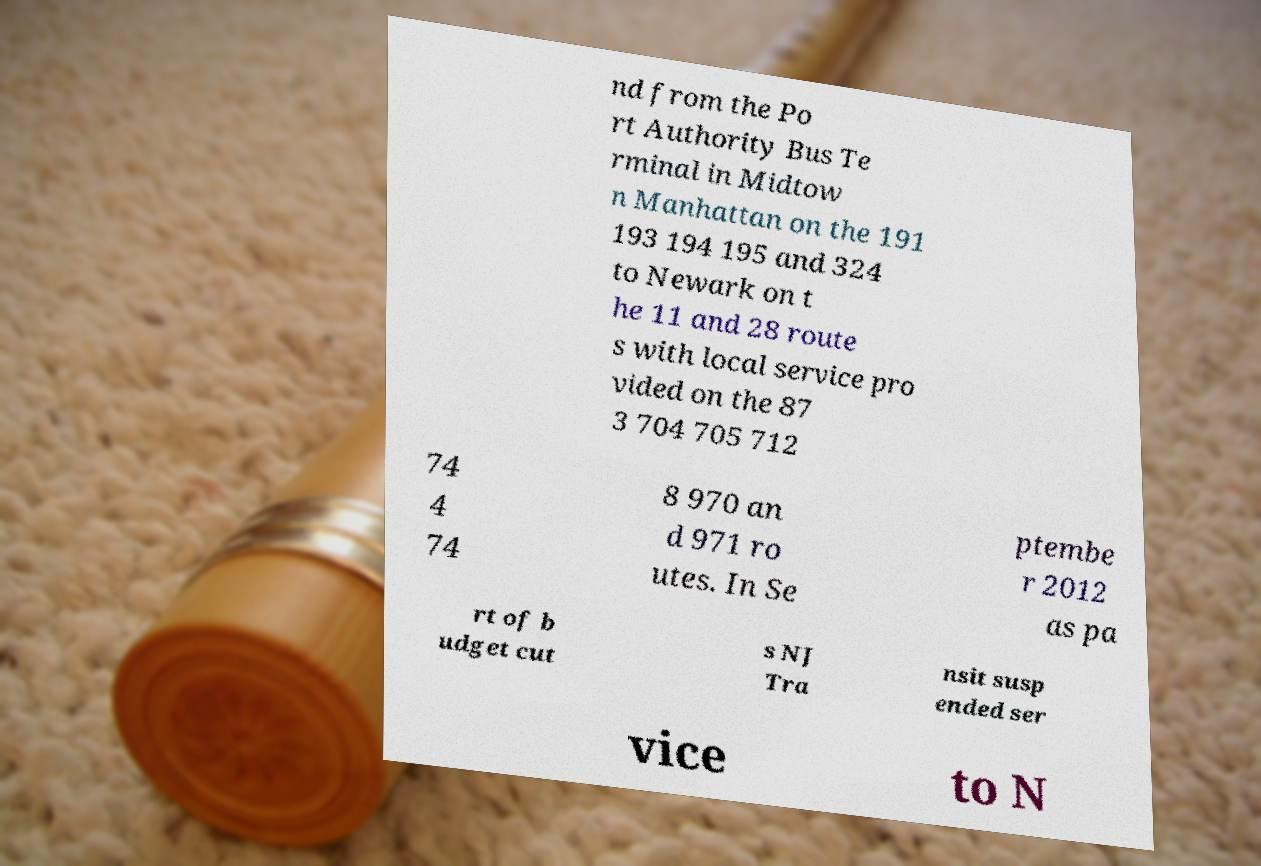There's text embedded in this image that I need extracted. Can you transcribe it verbatim? nd from the Po rt Authority Bus Te rminal in Midtow n Manhattan on the 191 193 194 195 and 324 to Newark on t he 11 and 28 route s with local service pro vided on the 87 3 704 705 712 74 4 74 8 970 an d 971 ro utes. In Se ptembe r 2012 as pa rt of b udget cut s NJ Tra nsit susp ended ser vice to N 